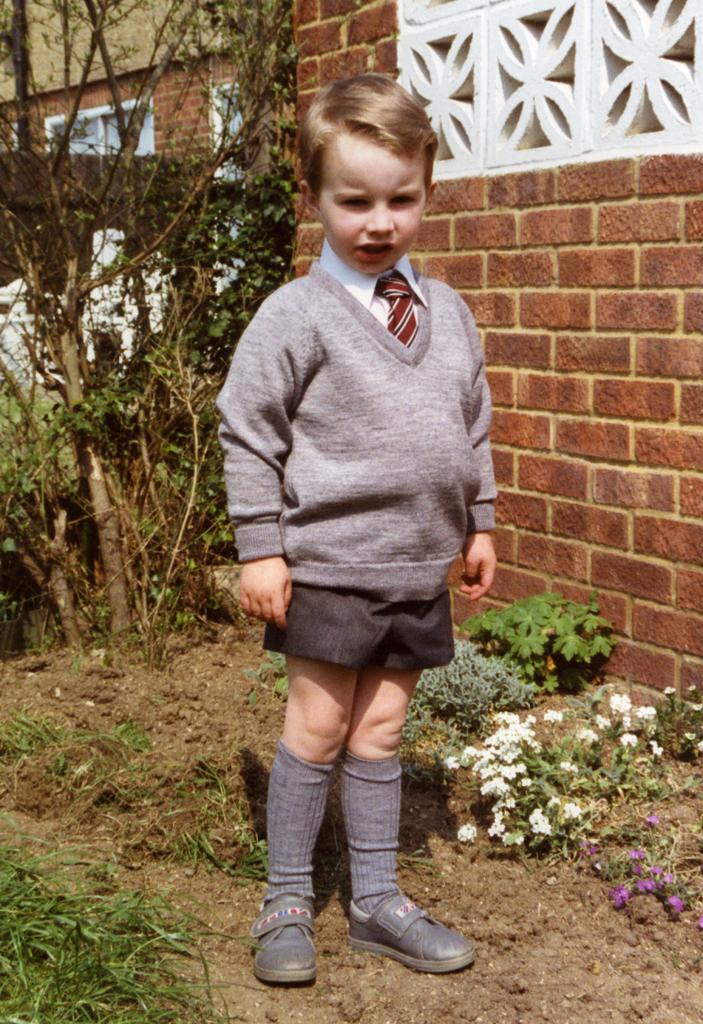What is the main subject of the image? There is a boy standing in the image. What type of natural environment is visible in the image? There is grass visible in the image. What type of flora can be seen in the image? There are flowers and plants in the image. What type of man-made structure is visible in the image? There is a brick wall in the image. What other objects are present in the image? There are other objects present in the image, but their specific details are not mentioned in the provided facts. How many wrists are visible in the image? There is no mention of wrists in the provided facts, so it cannot be determined from the image. Is there a sink visible in the image? There is no mention of a sink in the provided facts, so it cannot be determined from the image. 